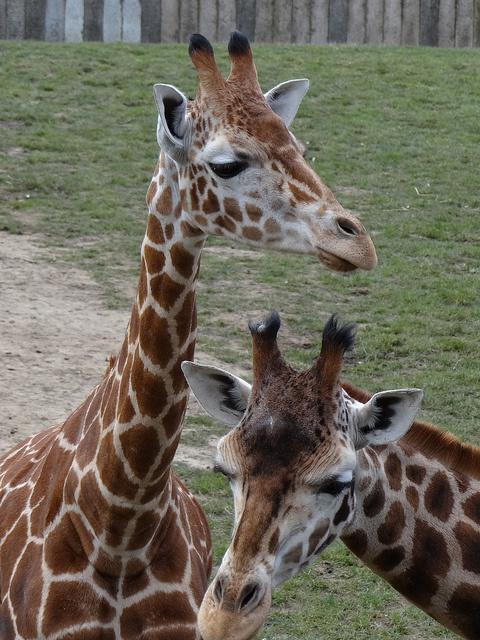Describe the objects in this image and their specific colors. I can see giraffe in gray, black, maroon, and darkgray tones and giraffe in gray, black, maroon, and darkgray tones in this image. 